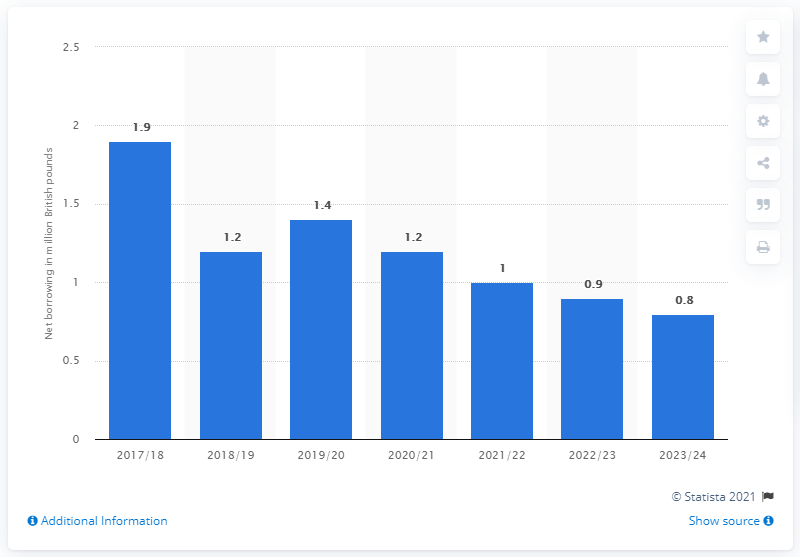Point out several critical features in this image. This statistic shows the UK's public sector net borrowing for the year 2023/24. The decrease in public sector net borrowing in the UK began in the financial year 2017/18. 